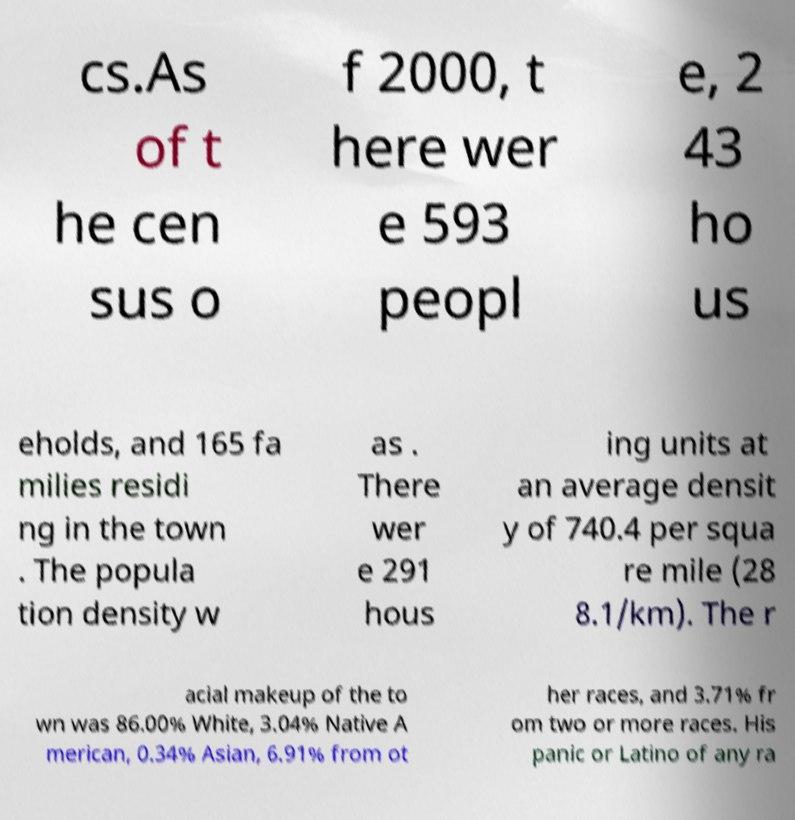Please identify and transcribe the text found in this image. cs.As of t he cen sus o f 2000, t here wer e 593 peopl e, 2 43 ho us eholds, and 165 fa milies residi ng in the town . The popula tion density w as . There wer e 291 hous ing units at an average densit y of 740.4 per squa re mile (28 8.1/km). The r acial makeup of the to wn was 86.00% White, 3.04% Native A merican, 0.34% Asian, 6.91% from ot her races, and 3.71% fr om two or more races. His panic or Latino of any ra 